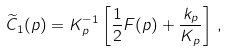Convert formula to latex. <formula><loc_0><loc_0><loc_500><loc_500>\widetilde { C } _ { 1 } ( p ) = K _ { p } ^ { - 1 } \left [ \frac { 1 } { 2 } F ( p ) + \frac { k _ { p } } { K _ { p } } \right ] \, ,</formula> 